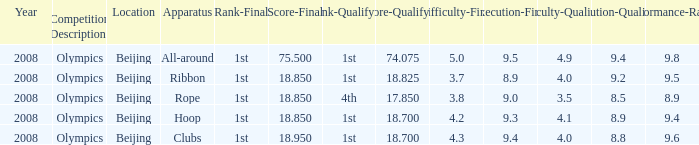What was her lowest final score with a qualifying score of 74.075? 75.5. 